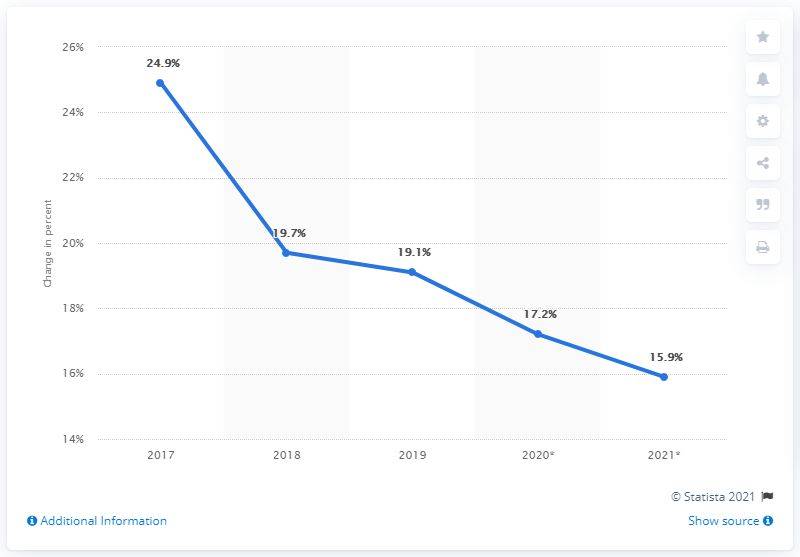Point out several critical features in this image. Amazon's e-retail sales increased by 19.1% in 2019. 